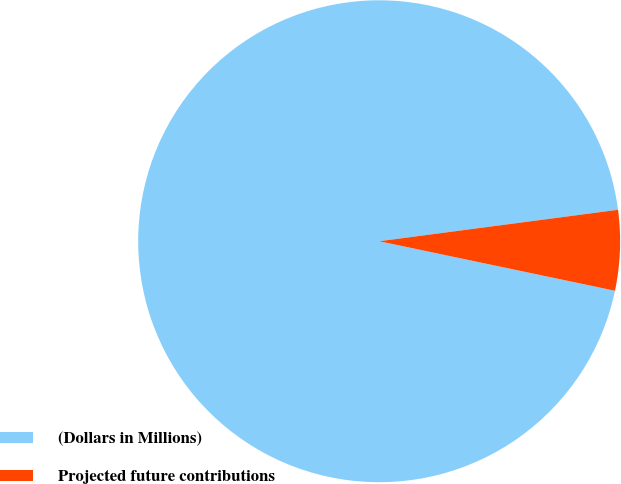Convert chart. <chart><loc_0><loc_0><loc_500><loc_500><pie_chart><fcel>(Dollars in Millions)<fcel>Projected future contributions<nl><fcel>94.62%<fcel>5.38%<nl></chart> 